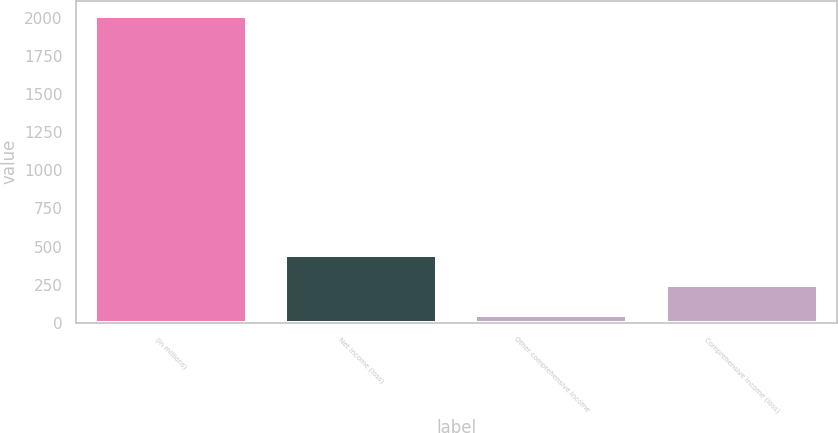<chart> <loc_0><loc_0><loc_500><loc_500><bar_chart><fcel>(in millions)<fcel>Net income (loss)<fcel>Other comprehensive income<fcel>Comprehensive income (loss)<nl><fcel>2012<fcel>444<fcel>52<fcel>248<nl></chart> 